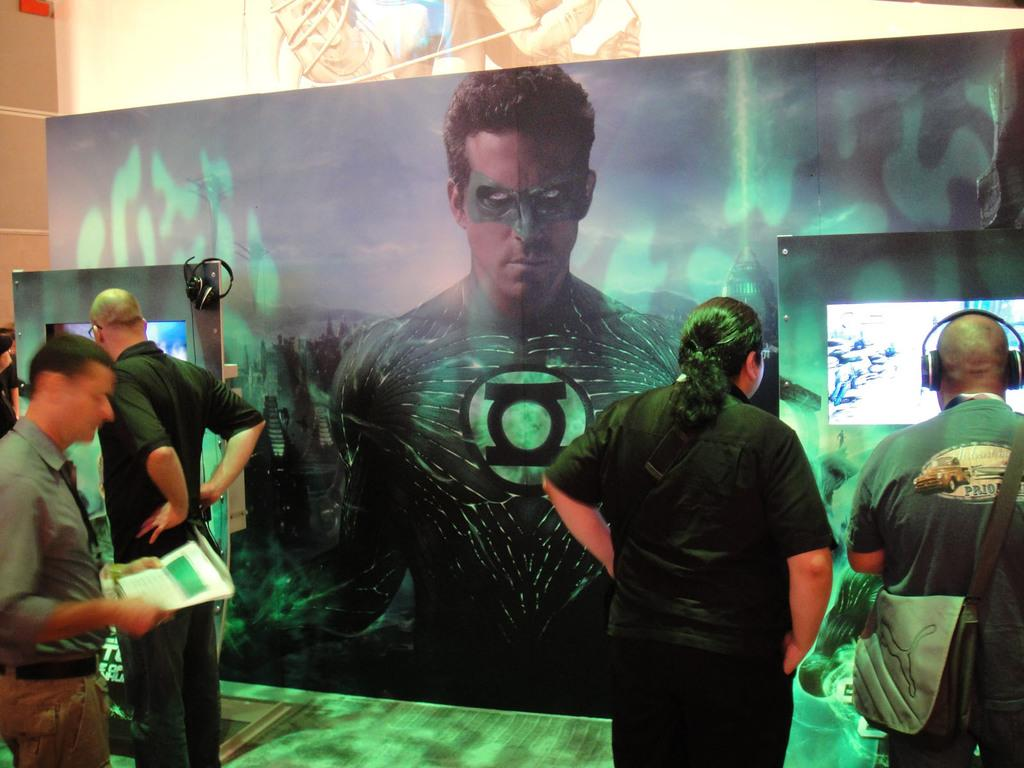What can be seen in the foreground of the image? There are people standing in front of the image. Where are the people standing in relation to the floor? The people are standing on the floor. What is visible in the background of the image? There are banners and screens in the background of the image. What type of celery is being used as a prop in the image? There is no celery present in the image. 